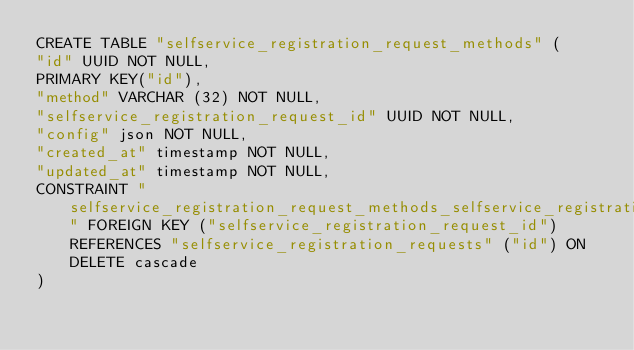Convert code to text. <code><loc_0><loc_0><loc_500><loc_500><_SQL_>CREATE TABLE "selfservice_registration_request_methods" (
"id" UUID NOT NULL,
PRIMARY KEY("id"),
"method" VARCHAR (32) NOT NULL,
"selfservice_registration_request_id" UUID NOT NULL,
"config" json NOT NULL,
"created_at" timestamp NOT NULL,
"updated_at" timestamp NOT NULL,
CONSTRAINT "selfservice_registration_request_methods_selfservice_registration_requests_id_fk" FOREIGN KEY ("selfservice_registration_request_id") REFERENCES "selfservice_registration_requests" ("id") ON DELETE cascade
)</code> 